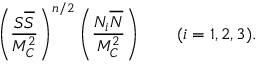<formula> <loc_0><loc_0><loc_500><loc_500>\left ( { \frac { S { \overline { S } } } { M _ { C } ^ { 2 } } } \right ) ^ { n / 2 } \left ( { \frac { N _ { i } { \overline { N } } } { M _ { C } ^ { 2 } } } \right ) \quad ( i = 1 , 2 , 3 ) .</formula> 